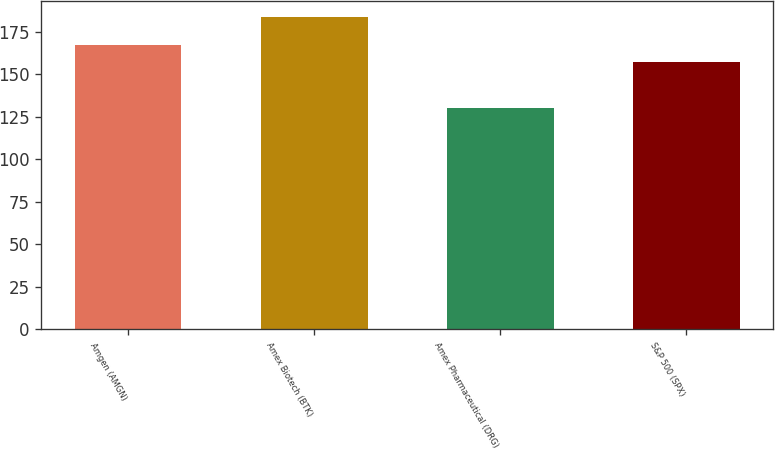<chart> <loc_0><loc_0><loc_500><loc_500><bar_chart><fcel>Amgen (AMGN)<fcel>Amex Biotech (BTK)<fcel>Amex Pharmaceutical (DRG)<fcel>S&P 500 (SPX)<nl><fcel>167.33<fcel>183.58<fcel>129.83<fcel>157.26<nl></chart> 